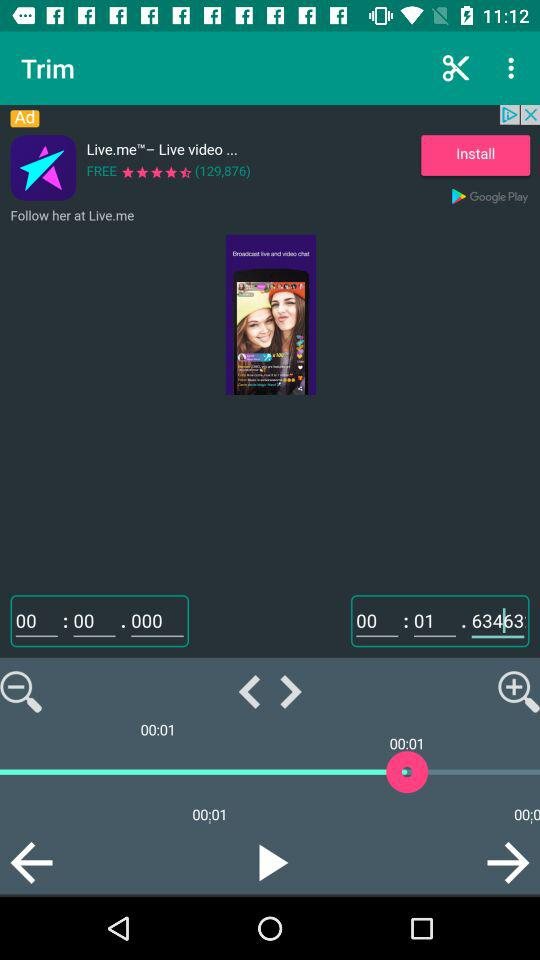What is the rating for the application? The rating for the application is 4.5 stars. 